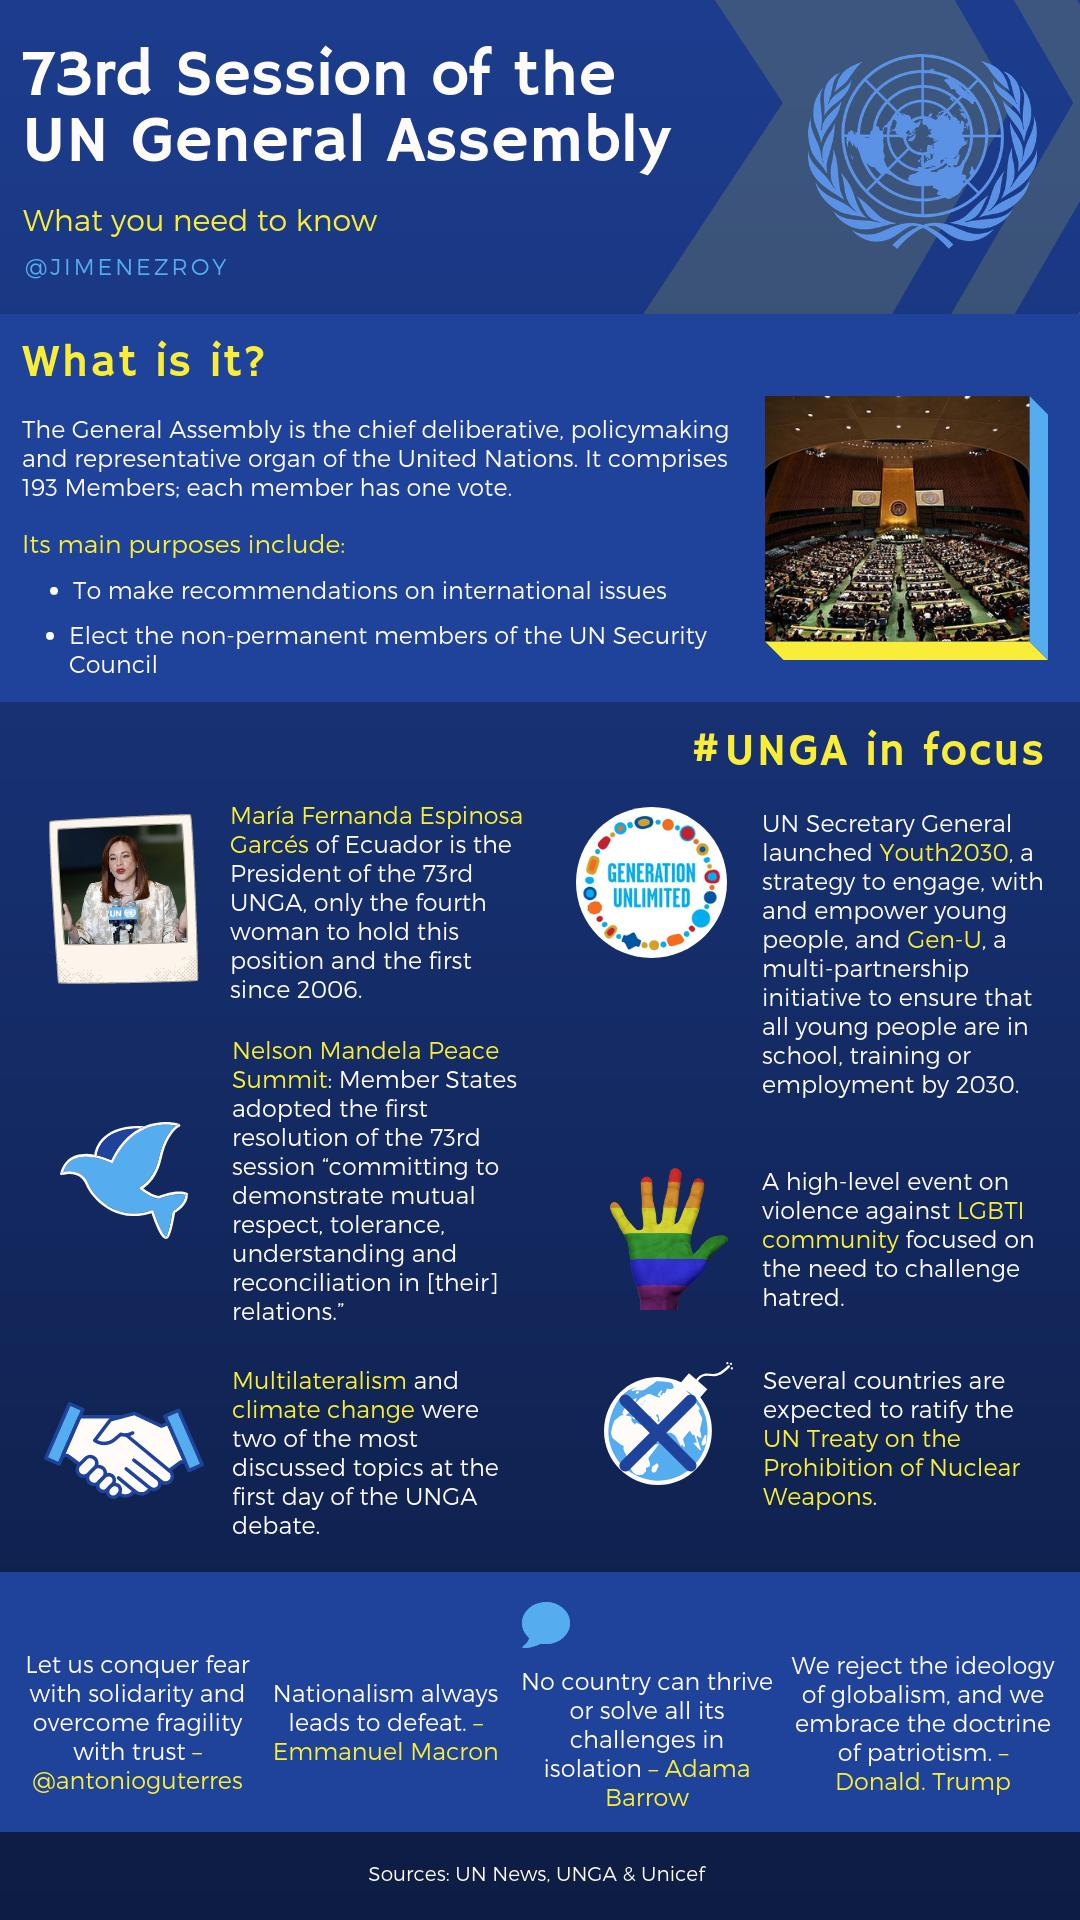Point out several critical features in this image. The target year for both Youth2030 and Gen-U is 2030. The UN General Assembly, commonly referred to as UNGA, is a gathering of representatives from member states of the United Nations. 